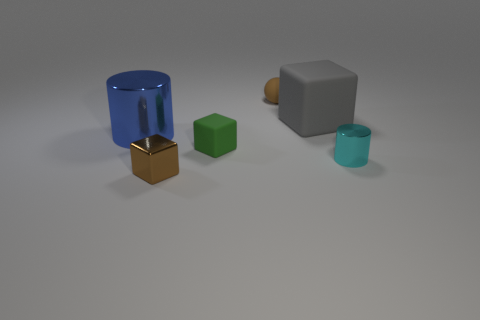Add 1 small purple matte cylinders. How many objects exist? 7 Subtract all spheres. How many objects are left? 5 Add 2 large blue metallic cylinders. How many large blue metallic cylinders are left? 3 Add 1 large blue shiny cylinders. How many large blue shiny cylinders exist? 2 Subtract 0 cyan blocks. How many objects are left? 6 Subtract all tiny things. Subtract all large gray matte things. How many objects are left? 1 